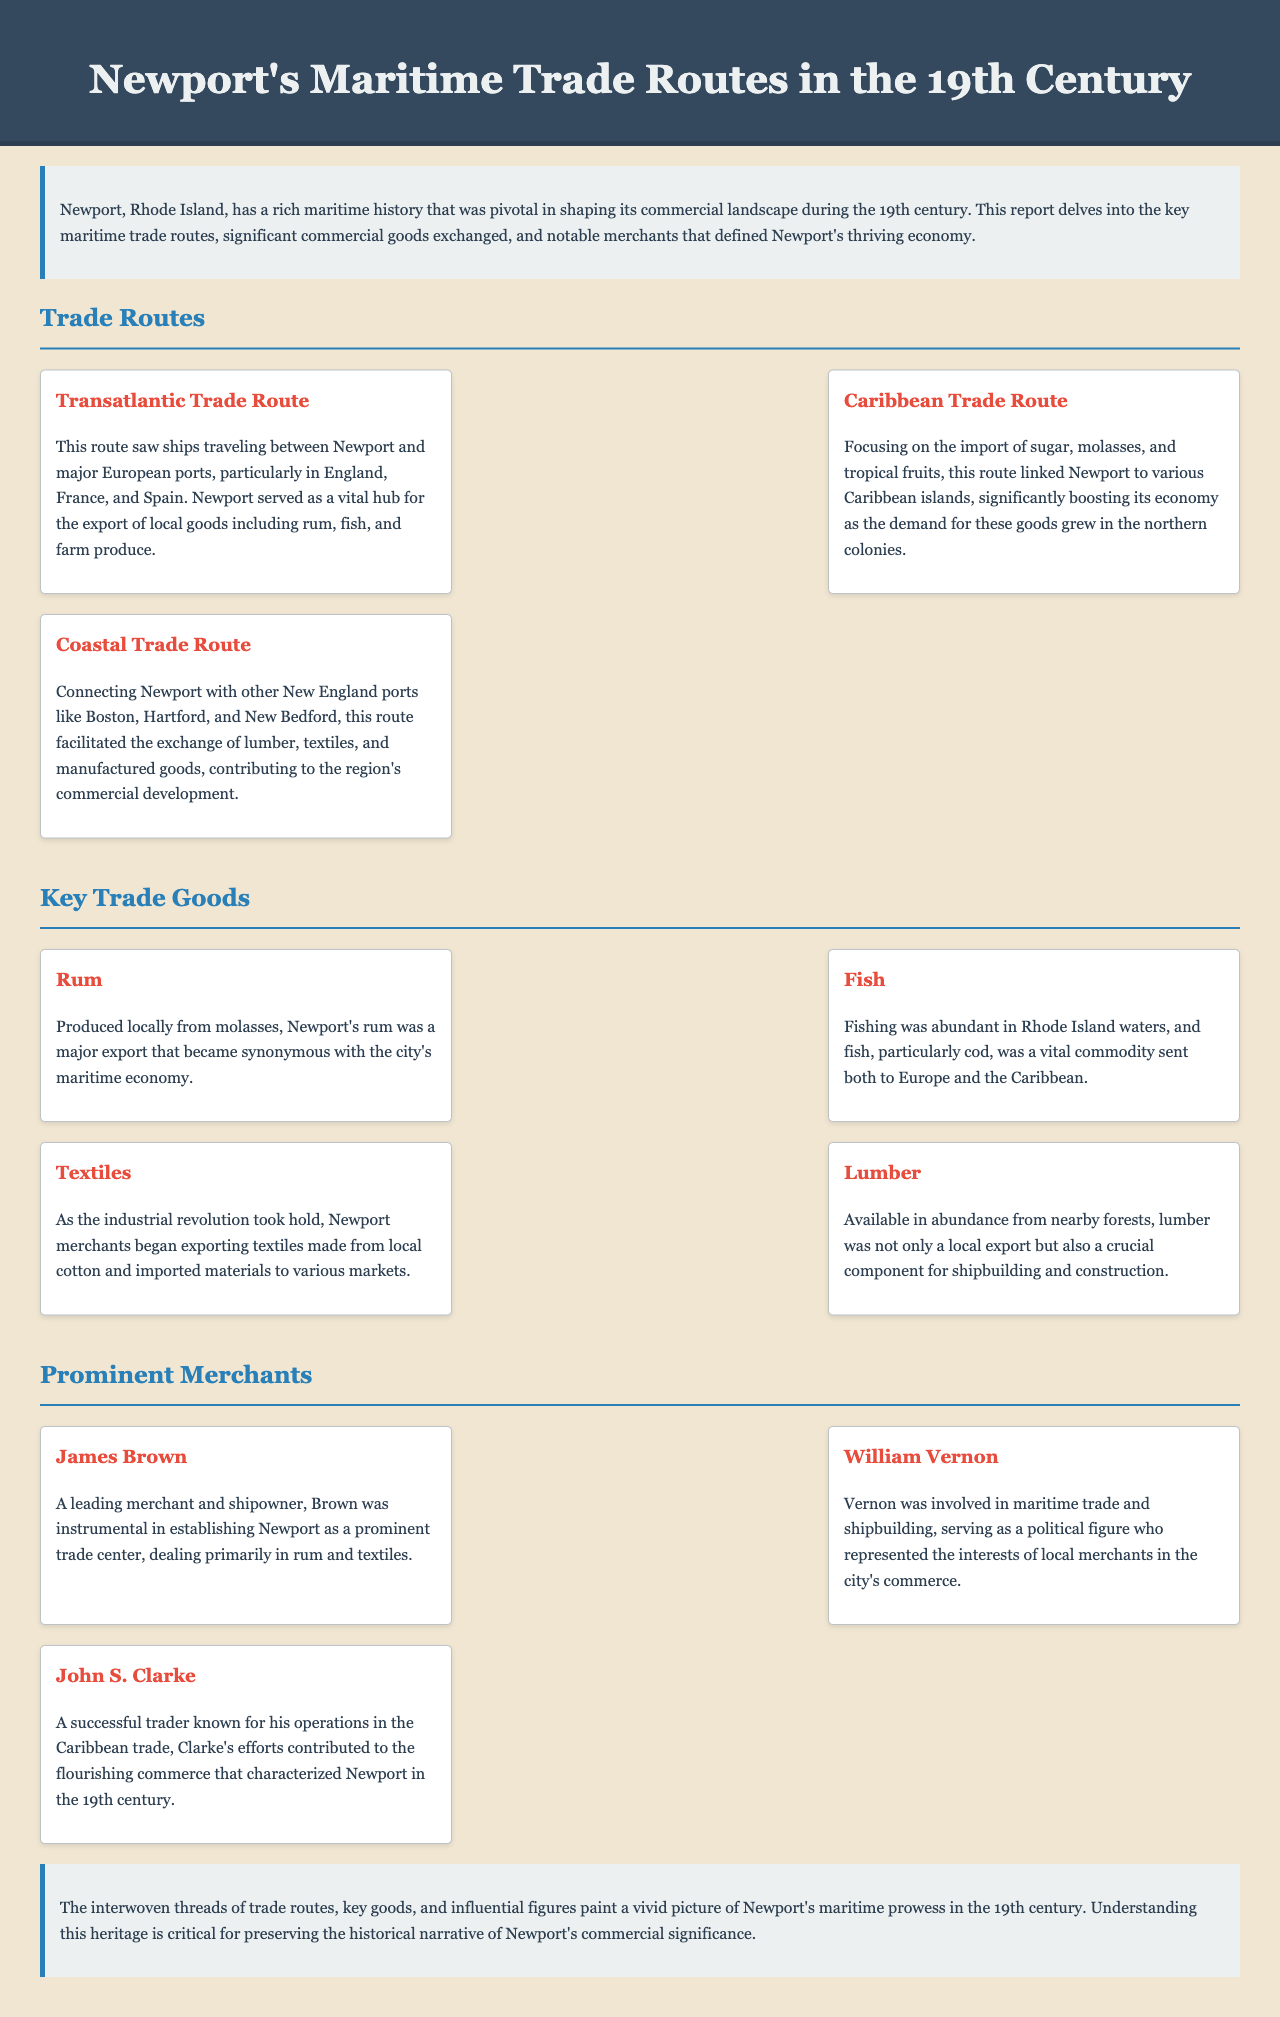What were the three main trade routes mentioned? The document lists the Transatlantic Trade Route, Caribbean Trade Route, and Coastal Trade Route as the three main trade routes.
Answer: Transatlantic Trade Route, Caribbean Trade Route, Coastal Trade Route What was a major export produced from molasses? The report states that rum was produced locally from molasses and became a major export.
Answer: Rum Which merchant was known for operations in the Caribbean trade? John S. Clarke was described as a successful trader known for his operations in the Caribbean trade.
Answer: John S. Clarke What key good was vital for shipbuilding? The document mentions that lumber was a crucial component for shipbuilding.
Answer: Lumber Which European countries were highlighted for the Transatlantic Trade Route? The Transatlantic Trade Route involved ships traveling between Newport and major European ports in England, France, and Spain.
Answer: England, France, Spain Who was a leading merchant dealing primarily in rum and textiles? James Brown was identified as a leading merchant and shipowner dealing primarily in rum and textiles.
Answer: James Brown What economic impact did the Caribbean Trade Route have on Newport? The Caribbean Trade Route significantly boosted Newport's economy as demand for sugar, molasses, and tropical fruits grew in the northern colonies.
Answer: Boosted economy What was a vital commodity from Rhode Island waters? The document states that fish, particularly cod, was a vital commodity sent both to Europe and the Caribbean.
Answer: Fish What type of report is this document classified as? The document is classified as a report that explores Newport's maritime trade routes in the 19th century.
Answer: Report 